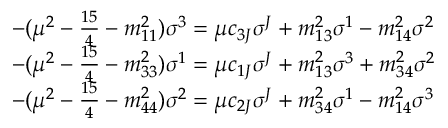Convert formula to latex. <formula><loc_0><loc_0><loc_500><loc_500>\begin{array} { l } { { - ( \mu ^ { 2 } - \frac { 1 5 } { 4 } - m _ { 1 1 } ^ { 2 } ) \sigma ^ { 3 } = \mu c _ { 3 J } \sigma ^ { J } + m _ { 1 3 } ^ { 2 } \sigma ^ { 1 } - m _ { 1 4 } ^ { 2 } \sigma ^ { 2 } } } \\ { { - ( \mu ^ { 2 } - \frac { 1 5 } { 4 } - m _ { 3 3 } ^ { 2 } ) \sigma ^ { 1 } = \mu c _ { 1 J } \sigma ^ { J } + m _ { 1 3 } ^ { 2 } \sigma ^ { 3 } + m _ { 3 4 } ^ { 2 } \sigma ^ { 2 } } } \\ { { - ( \mu ^ { 2 } - \frac { 1 5 } { 4 } - m _ { 4 4 } ^ { 2 } ) \sigma ^ { 2 } = \mu c _ { 2 J } \sigma ^ { J } + m _ { 3 4 } ^ { 2 } \sigma ^ { 1 } - m _ { 1 4 } ^ { 2 } \sigma ^ { 3 } } } \end{array}</formula> 